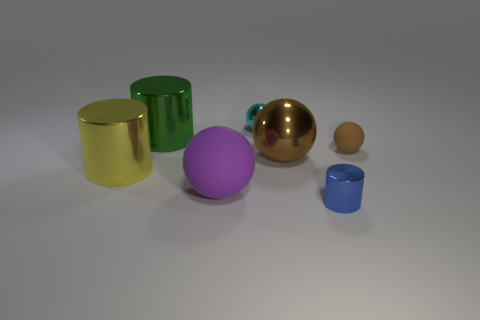Add 1 tiny gray matte cylinders. How many objects exist? 8 Subtract all cylinders. How many objects are left? 4 Subtract 0 yellow cubes. How many objects are left? 7 Subtract all small blue rubber cylinders. Subtract all green cylinders. How many objects are left? 6 Add 1 small brown matte objects. How many small brown matte objects are left? 2 Add 3 small cylinders. How many small cylinders exist? 4 